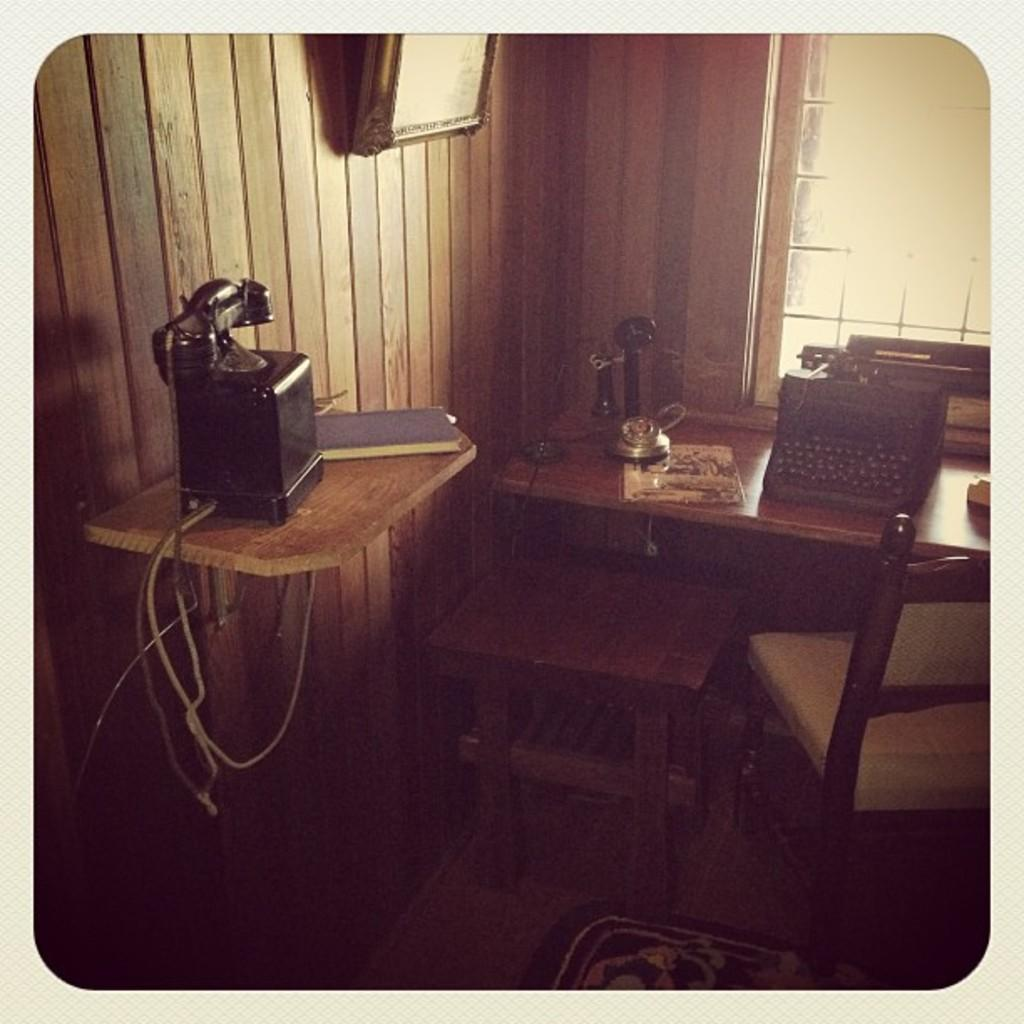What is the main object in the image? There is a typing machine in the image. What else can be seen on the table with the typing machine? There are other objects on the table. What piece of furniture is in the image? There is a chair in the image. What type of wall is visible in the image? There is a wooden wall with an attached object. Can you describe any other objects in the image? There are other objects in the image. What type of quilt is being used by the minister in the image? There is no minister or quilt present in the image. How many ants can be seen crawling on the typing machine in the image? There are no ants visible in the image. 